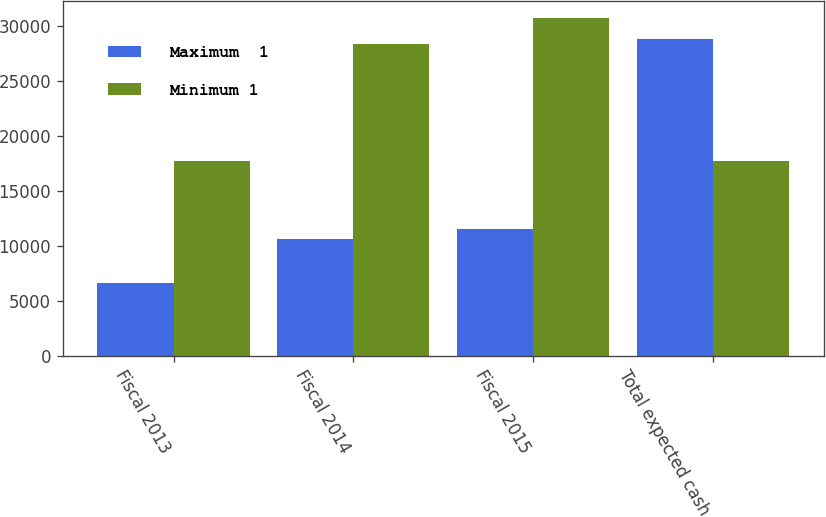<chart> <loc_0><loc_0><loc_500><loc_500><stacked_bar_chart><ecel><fcel>Fiscal 2013<fcel>Fiscal 2014<fcel>Fiscal 2015<fcel>Total expected cash<nl><fcel>Maximum  1<fcel>6624<fcel>10616<fcel>11529<fcel>28769<nl><fcel>Minimum 1<fcel>17664<fcel>28309<fcel>30745<fcel>17664<nl></chart> 